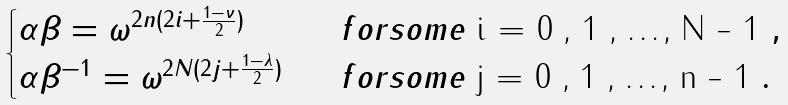Convert formula to latex. <formula><loc_0><loc_0><loc_500><loc_500>\begin{cases} \alpha \beta = \omega ^ { 2 n ( 2 i + \frac { 1 - \nu } { 2 } ) } & \ \ f o r s o m e $ i = 0 , 1 , \dots , N - 1 $ , \\ \alpha \beta ^ { - 1 } = \omega ^ { 2 N ( 2 j + \frac { 1 - \lambda } { 2 } ) } & \ \ f o r s o m e $ j = 0 , 1 , \dots , n - 1 $ . \end{cases}</formula> 